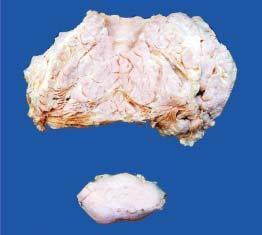does lower part of the image show a separate encapsulated gelatinous mass?
Answer the question using a single word or phrase. Yes 